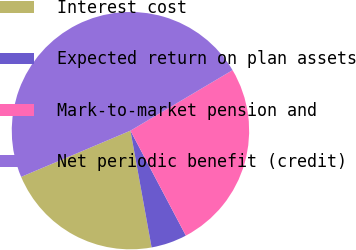Convert chart to OTSL. <chart><loc_0><loc_0><loc_500><loc_500><pie_chart><fcel>Interest cost<fcel>Expected return on plan assets<fcel>Mark-to-market pension and<fcel>Net periodic benefit (credit)<nl><fcel>21.48%<fcel>4.88%<fcel>25.78%<fcel>47.85%<nl></chart> 